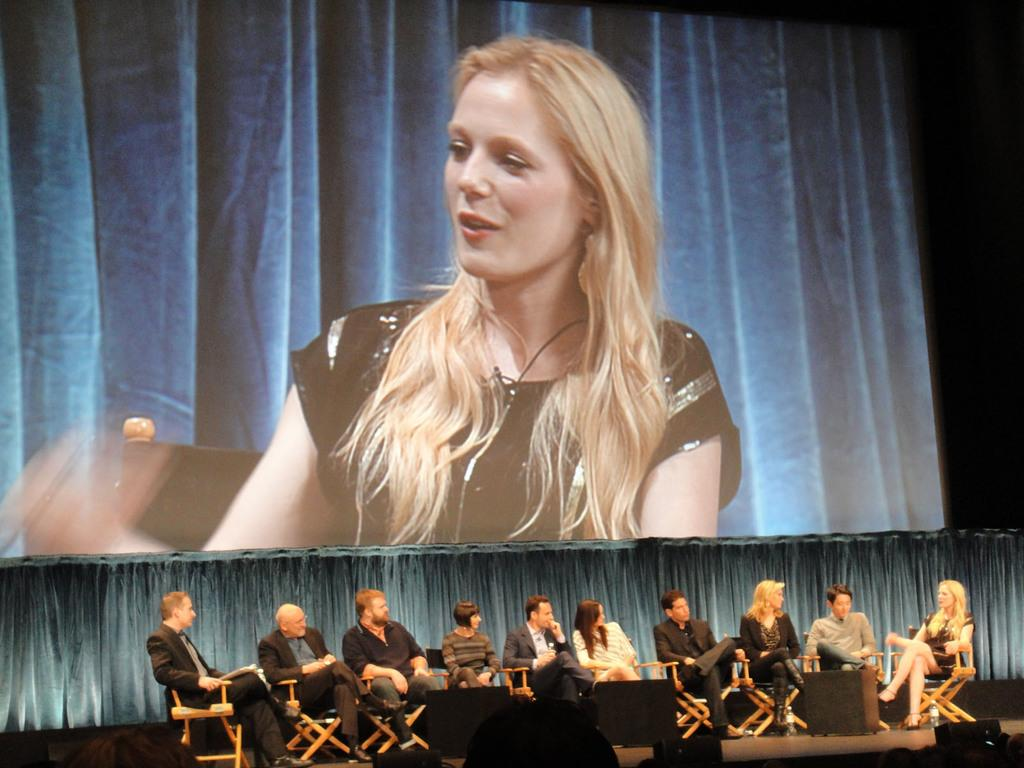What are the people in the image doing? The people in the image are sitting on chairs at the bottom of the image. What is behind the people sitting on chairs? There is a curtain behind the people sitting on chairs. What can be seen at the top of the image? At the top of the image, there is a screen. What is happening on the screen? On the screen, a woman is sitting and smiling. Can you hear the voice of the woman on the screen in the image? The image is silent, so there is no voice to be heard. 